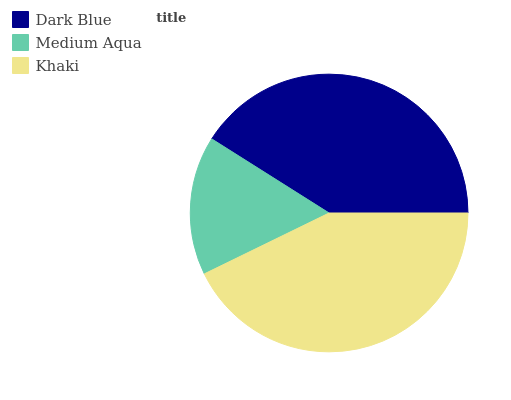Is Medium Aqua the minimum?
Answer yes or no. Yes. Is Khaki the maximum?
Answer yes or no. Yes. Is Khaki the minimum?
Answer yes or no. No. Is Medium Aqua the maximum?
Answer yes or no. No. Is Khaki greater than Medium Aqua?
Answer yes or no. Yes. Is Medium Aqua less than Khaki?
Answer yes or no. Yes. Is Medium Aqua greater than Khaki?
Answer yes or no. No. Is Khaki less than Medium Aqua?
Answer yes or no. No. Is Dark Blue the high median?
Answer yes or no. Yes. Is Dark Blue the low median?
Answer yes or no. Yes. Is Khaki the high median?
Answer yes or no. No. Is Medium Aqua the low median?
Answer yes or no. No. 